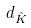<formula> <loc_0><loc_0><loc_500><loc_500>d _ { \hat { K } }</formula> 